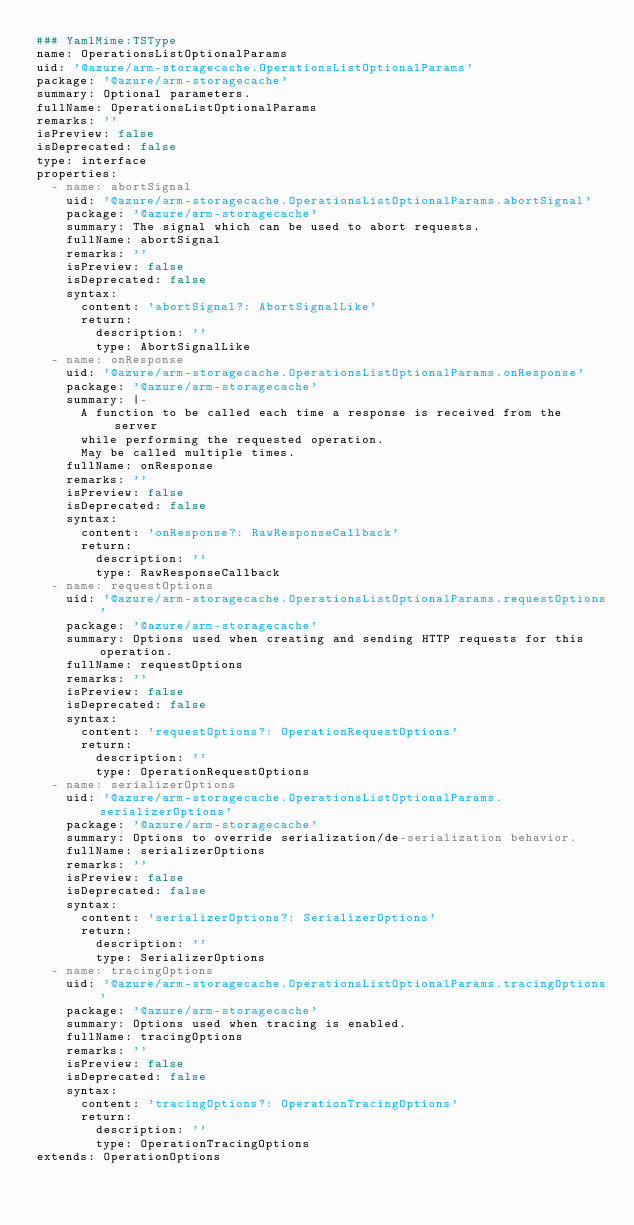Convert code to text. <code><loc_0><loc_0><loc_500><loc_500><_YAML_>### YamlMime:TSType
name: OperationsListOptionalParams
uid: '@azure/arm-storagecache.OperationsListOptionalParams'
package: '@azure/arm-storagecache'
summary: Optional parameters.
fullName: OperationsListOptionalParams
remarks: ''
isPreview: false
isDeprecated: false
type: interface
properties:
  - name: abortSignal
    uid: '@azure/arm-storagecache.OperationsListOptionalParams.abortSignal'
    package: '@azure/arm-storagecache'
    summary: The signal which can be used to abort requests.
    fullName: abortSignal
    remarks: ''
    isPreview: false
    isDeprecated: false
    syntax:
      content: 'abortSignal?: AbortSignalLike'
      return:
        description: ''
        type: AbortSignalLike
  - name: onResponse
    uid: '@azure/arm-storagecache.OperationsListOptionalParams.onResponse'
    package: '@azure/arm-storagecache'
    summary: |-
      A function to be called each time a response is received from the server
      while performing the requested operation.
      May be called multiple times.
    fullName: onResponse
    remarks: ''
    isPreview: false
    isDeprecated: false
    syntax:
      content: 'onResponse?: RawResponseCallback'
      return:
        description: ''
        type: RawResponseCallback
  - name: requestOptions
    uid: '@azure/arm-storagecache.OperationsListOptionalParams.requestOptions'
    package: '@azure/arm-storagecache'
    summary: Options used when creating and sending HTTP requests for this operation.
    fullName: requestOptions
    remarks: ''
    isPreview: false
    isDeprecated: false
    syntax:
      content: 'requestOptions?: OperationRequestOptions'
      return:
        description: ''
        type: OperationRequestOptions
  - name: serializerOptions
    uid: '@azure/arm-storagecache.OperationsListOptionalParams.serializerOptions'
    package: '@azure/arm-storagecache'
    summary: Options to override serialization/de-serialization behavior.
    fullName: serializerOptions
    remarks: ''
    isPreview: false
    isDeprecated: false
    syntax:
      content: 'serializerOptions?: SerializerOptions'
      return:
        description: ''
        type: SerializerOptions
  - name: tracingOptions
    uid: '@azure/arm-storagecache.OperationsListOptionalParams.tracingOptions'
    package: '@azure/arm-storagecache'
    summary: Options used when tracing is enabled.
    fullName: tracingOptions
    remarks: ''
    isPreview: false
    isDeprecated: false
    syntax:
      content: 'tracingOptions?: OperationTracingOptions'
      return:
        description: ''
        type: OperationTracingOptions
extends: OperationOptions
</code> 